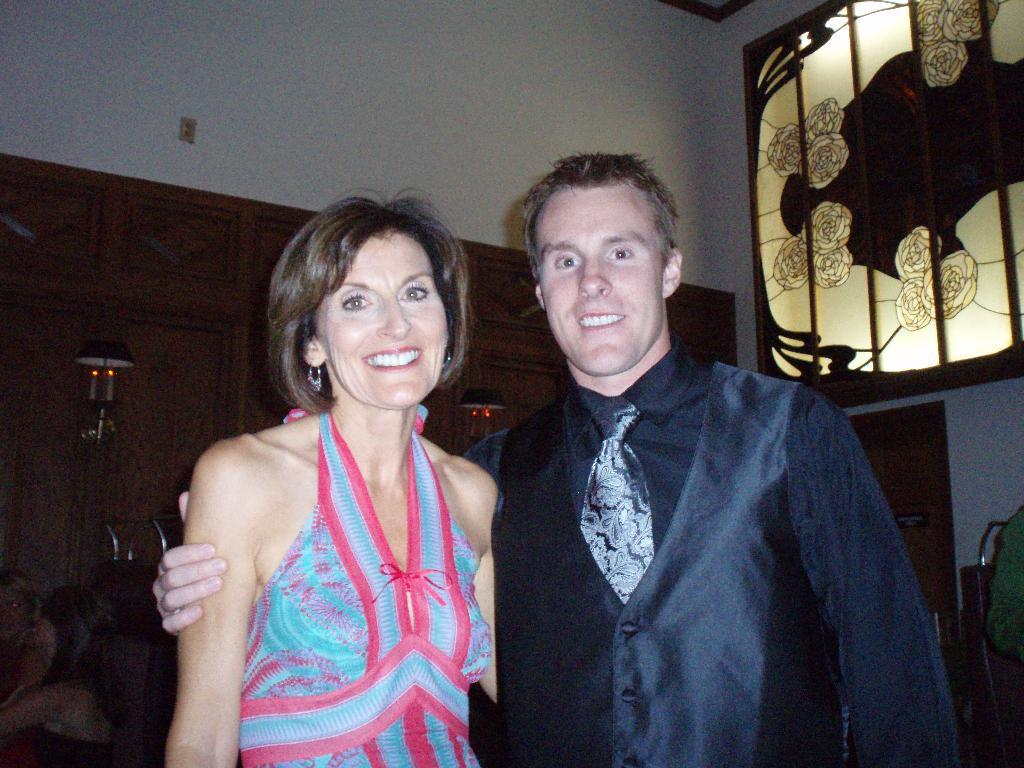Who are the people in the image? There is a man and a woman in the image. What expressions do the man and woman have? Both the man and woman are smiling. What can be seen in the background of the image? There is a wall and a stained glass in the background of the image. What type of needle is the man using to sew the woman's dress in the image? There is no needle or sewing activity present in the image. Can you tell me what the argument is about between the man and woman in the image? There is no argument depicted in the image; both the man and woman are smiling. 